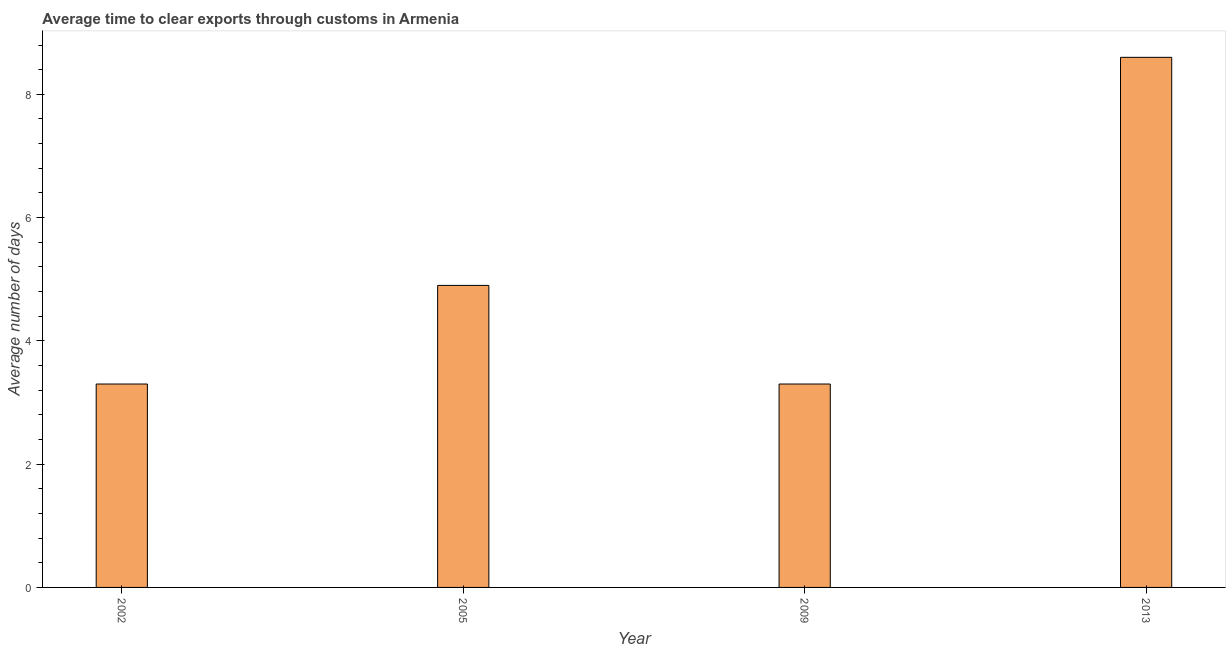Does the graph contain grids?
Your response must be concise. No. What is the title of the graph?
Offer a terse response. Average time to clear exports through customs in Armenia. What is the label or title of the X-axis?
Provide a short and direct response. Year. What is the label or title of the Y-axis?
Provide a succinct answer. Average number of days. What is the time to clear exports through customs in 2005?
Offer a very short reply. 4.9. Across all years, what is the maximum time to clear exports through customs?
Provide a short and direct response. 8.6. In which year was the time to clear exports through customs maximum?
Give a very brief answer. 2013. What is the sum of the time to clear exports through customs?
Your answer should be compact. 20.1. What is the average time to clear exports through customs per year?
Keep it short and to the point. 5.03. What is the median time to clear exports through customs?
Keep it short and to the point. 4.1. Do a majority of the years between 2009 and 2005 (inclusive) have time to clear exports through customs greater than 6.4 days?
Provide a short and direct response. No. What is the ratio of the time to clear exports through customs in 2002 to that in 2013?
Ensure brevity in your answer.  0.38. What is the difference between the highest and the second highest time to clear exports through customs?
Provide a succinct answer. 3.7. Is the sum of the time to clear exports through customs in 2002 and 2005 greater than the maximum time to clear exports through customs across all years?
Give a very brief answer. No. What is the difference between the highest and the lowest time to clear exports through customs?
Ensure brevity in your answer.  5.3. In how many years, is the time to clear exports through customs greater than the average time to clear exports through customs taken over all years?
Keep it short and to the point. 1. How many bars are there?
Your answer should be very brief. 4. How many years are there in the graph?
Ensure brevity in your answer.  4. What is the difference between two consecutive major ticks on the Y-axis?
Provide a succinct answer. 2. What is the Average number of days in 2002?
Your answer should be compact. 3.3. What is the Average number of days of 2005?
Provide a short and direct response. 4.9. What is the Average number of days of 2013?
Offer a terse response. 8.6. What is the difference between the Average number of days in 2002 and 2009?
Provide a succinct answer. 0. What is the difference between the Average number of days in 2002 and 2013?
Make the answer very short. -5.3. What is the difference between the Average number of days in 2005 and 2009?
Your answer should be very brief. 1.6. What is the difference between the Average number of days in 2005 and 2013?
Your response must be concise. -3.7. What is the difference between the Average number of days in 2009 and 2013?
Provide a succinct answer. -5.3. What is the ratio of the Average number of days in 2002 to that in 2005?
Provide a short and direct response. 0.67. What is the ratio of the Average number of days in 2002 to that in 2013?
Make the answer very short. 0.38. What is the ratio of the Average number of days in 2005 to that in 2009?
Your answer should be very brief. 1.49. What is the ratio of the Average number of days in 2005 to that in 2013?
Your answer should be compact. 0.57. What is the ratio of the Average number of days in 2009 to that in 2013?
Make the answer very short. 0.38. 